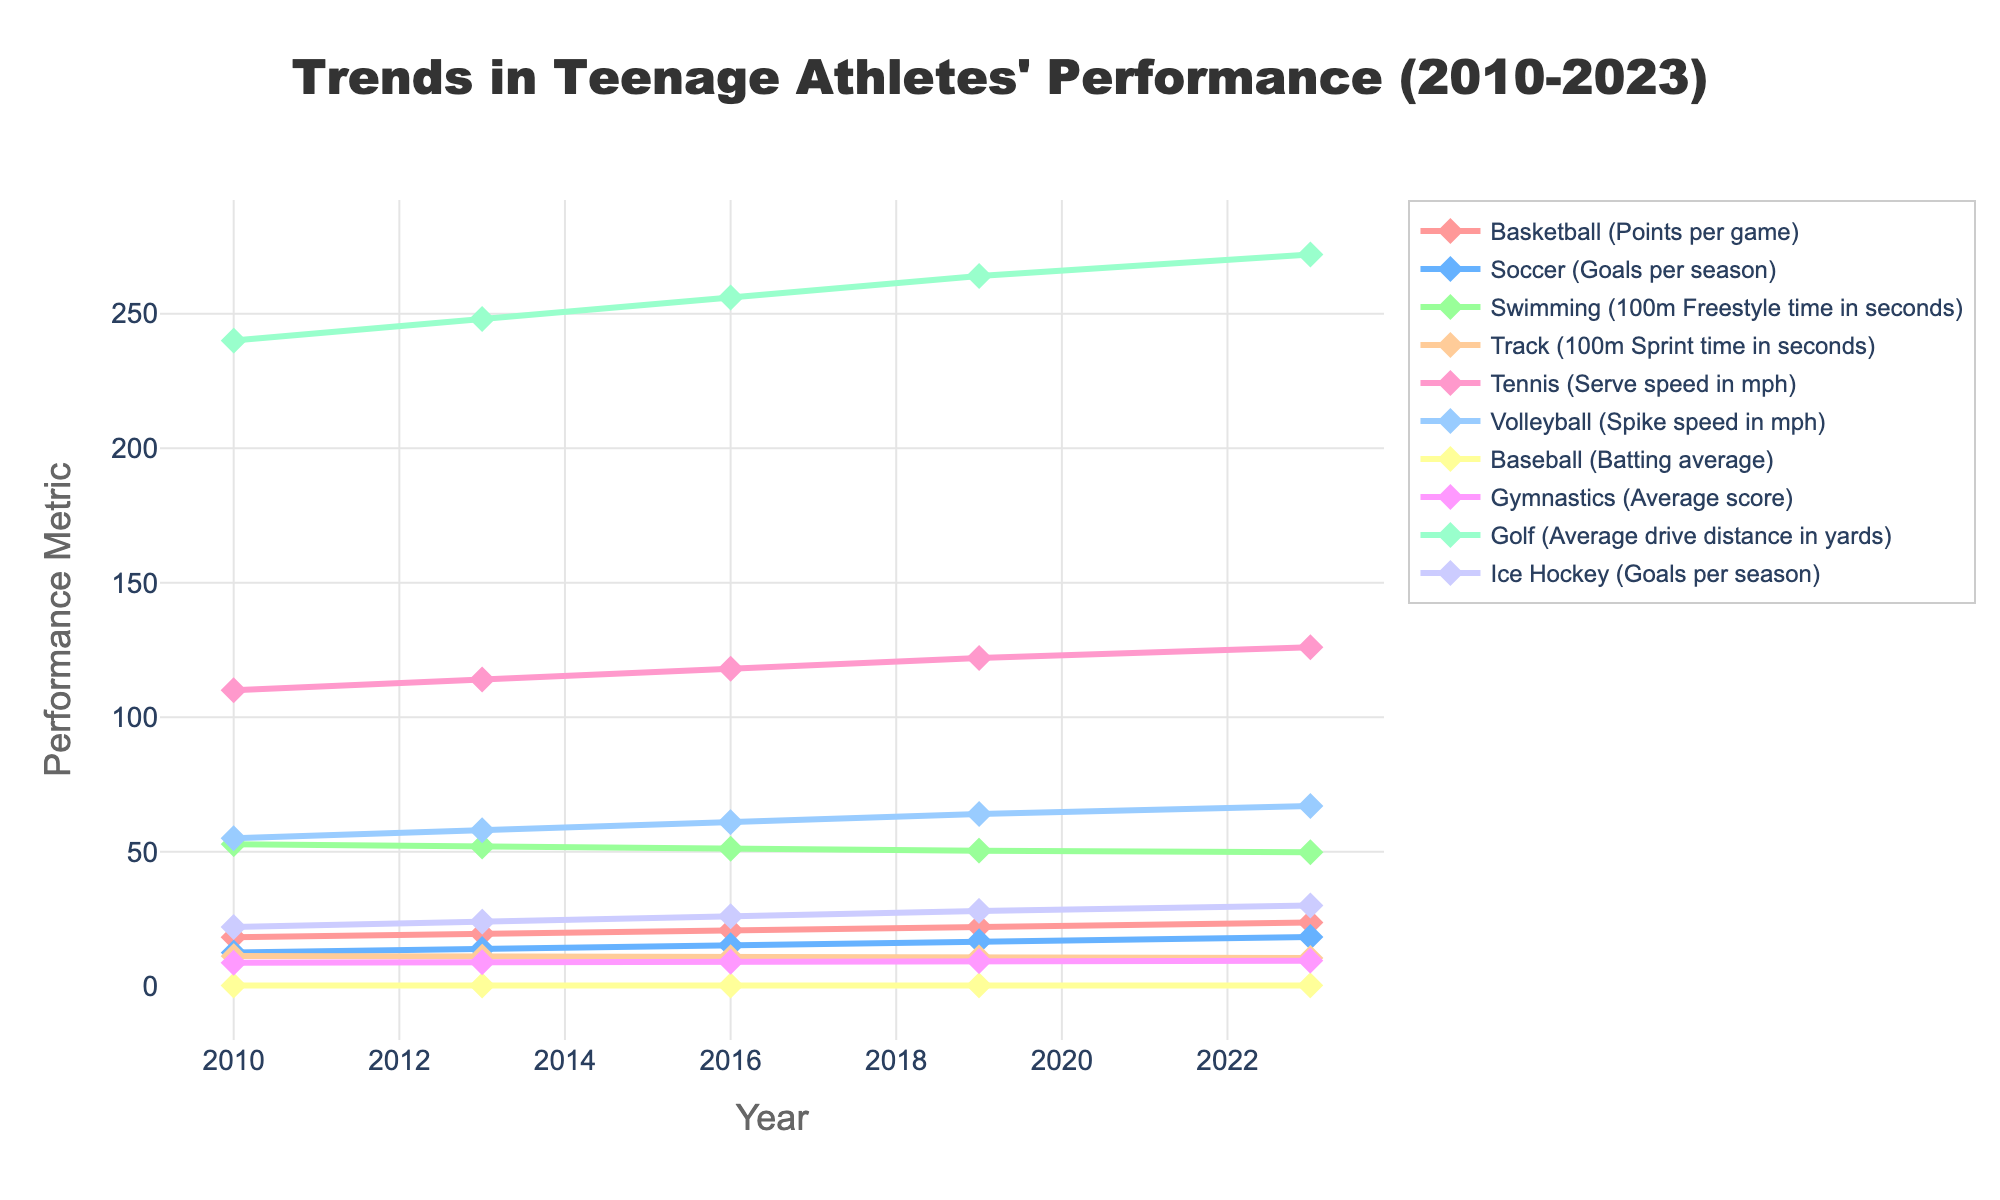What's the improvement in points per game for teenage basketball players from 2010 to 2023? First, identify the points per game for basketball in 2010 and 2023, which are 18.2 and 23.7 respectively. Subtract the 2010 value from the 2023 value: 23.7 - 18.2 = 5.5.
Answer: 5.5 Which sport showed the most improvement in terms of spike speed from 2010 to 2023? Find the spike speed for volleyball in 2010 and 2023, which are 55 mph and 67 mph respectively. Calculate the difference: 67 - 55 = 12 mph. Volleyball has the highest improvement in spike speed.
Answer: Volleyball Compare the average score improvement in gymnastics to the serve speed improvement in tennis from 2010 to 2023. Which has improved more? Identify the average score in gymnastics (8.7 in 2010 to 9.5 in 2023), improvement is 9.5 - 8.7 = 0.8. For tennis (110 mph in 2010 to 126 mph in 2023), improvement is 126 - 110 = 16 mph. Tennis has a higher improvement.
Answer: Tennis What is the average 100m sprint time for track in the years shown? Identify the times for 100m sprint in 2010, 2013, 2016, 2019, and 2023: 11.2, 11.0, 10.8, 10.7, 10.5 respectively. Sum these times: 11.2 + 11.0 + 10.8 + 10.7 + 10.5 = 54.2. Then divide by the number of years (5): 54.2 / 5 = 10.84.
Answer: 10.84 